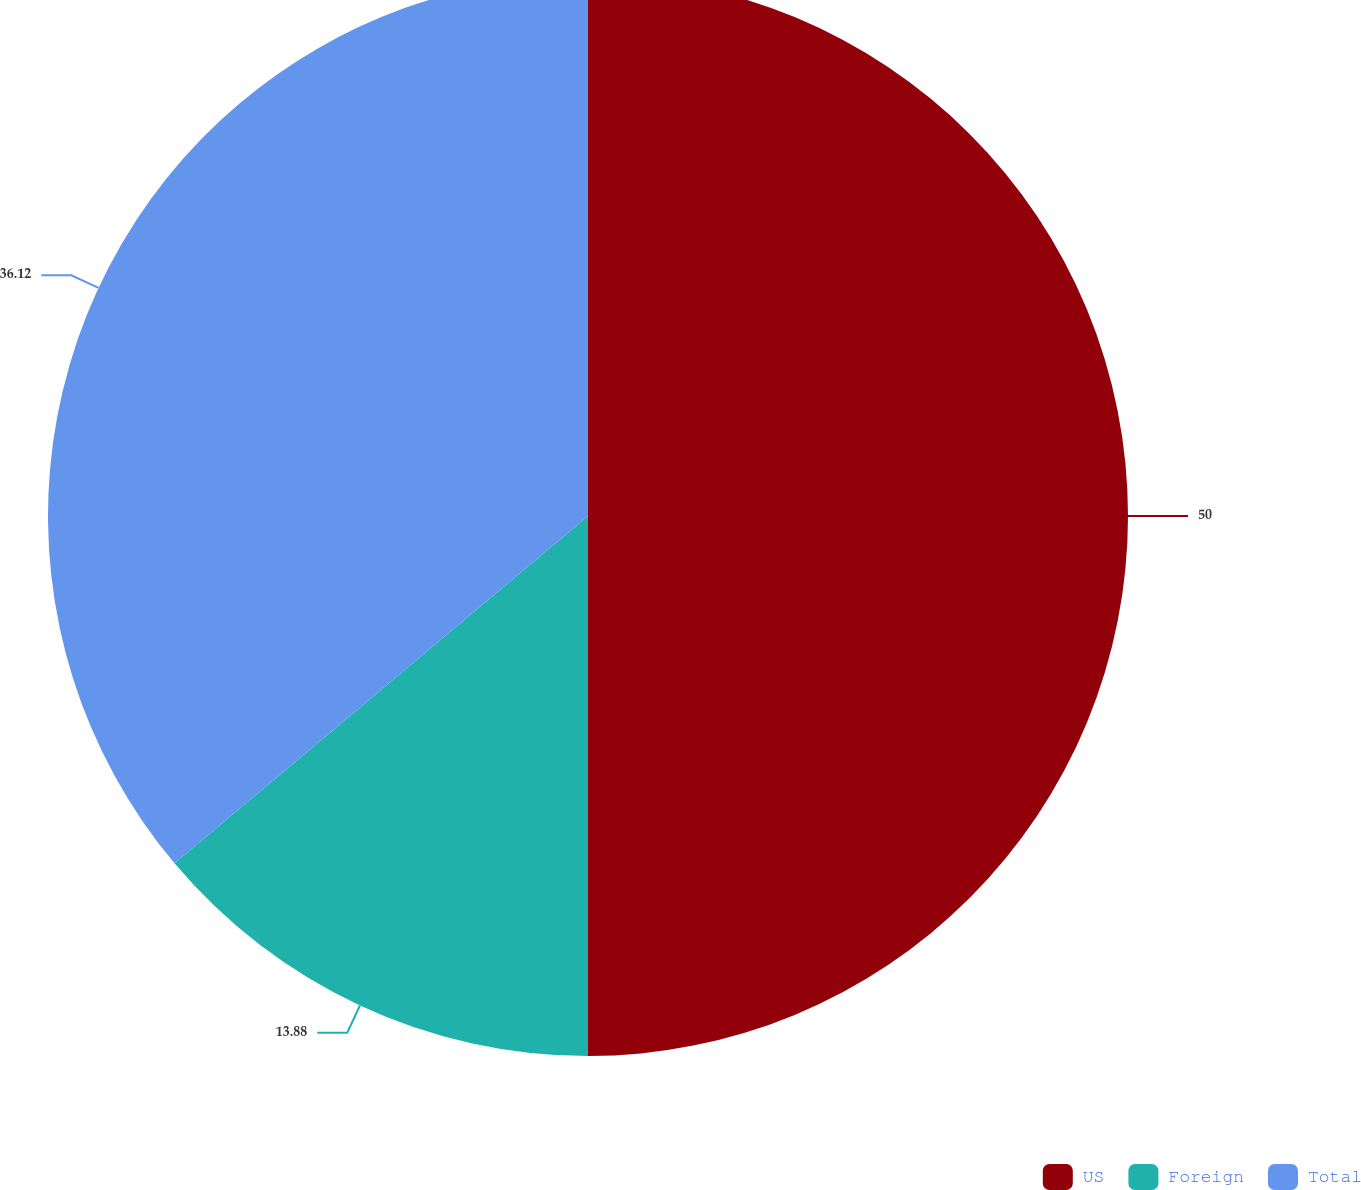Convert chart. <chart><loc_0><loc_0><loc_500><loc_500><pie_chart><fcel>US<fcel>Foreign<fcel>Total<nl><fcel>50.0%<fcel>13.88%<fcel>36.12%<nl></chart> 